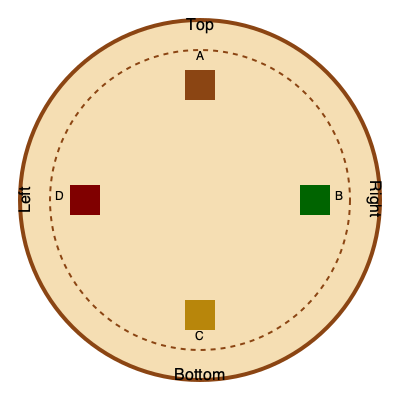In a traditional Polynesian earth oven (umu), cooking utensils are arranged in a specific order. Given the circular layout above representing the umu, which sequence correctly describes the arrangement of the following utensils from top to bottom, clockwise?

A: Wooden tongs
B: Banana leaf wraps
C: Stone tools
D: Coconut husk brushes To answer this question, we need to understand the traditional arrangement of utensils in a Polynesian earth oven (umu) and match it to the given diagram. Let's break it down step-by-step:

1. The umu is typically circular, as represented in the diagram.

2. The arrangement of utensils usually follows a logical order based on their use during the cooking process.

3. Starting from the top and moving clockwise:

   a. Wooden tongs (A) are usually placed at the top for easy access, as they're used to handle hot stones and food throughout the cooking process.
   
   b. Banana leaf wraps (B) are typically placed on the right side. They're used to wrap food before placing it in the umu, so they're needed early in the process.
   
   c. Stone tools (C) are often placed at the bottom. These are used for tasks like cracking coconuts or pounding taro, which are usually done after the umu is opened.
   
   d. Coconut husk brushes (D) are typically on the left side. They're used to clean the cooking area and sweep away ashes, which is often done at the beginning and end of the cooking process.

4. This arrangement allows for an efficient workflow around the umu, with each tool easily accessible when needed during the cooking process.

Therefore, the correct sequence from top to bottom, clockwise, is: A, B, C, D.
Answer: A, B, C, D 